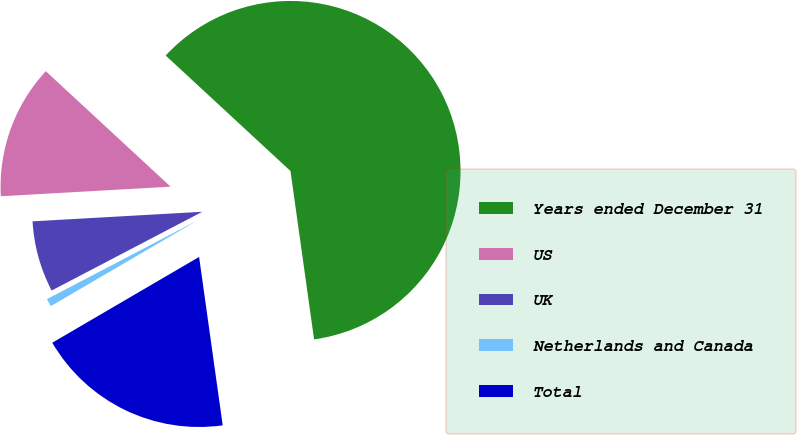Convert chart. <chart><loc_0><loc_0><loc_500><loc_500><pie_chart><fcel>Years ended December 31<fcel>US<fcel>UK<fcel>Netherlands and Canada<fcel>Total<nl><fcel>60.9%<fcel>12.78%<fcel>6.77%<fcel>0.75%<fcel>18.8%<nl></chart> 